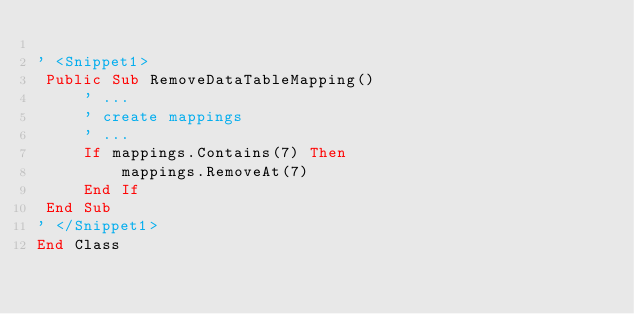<code> <loc_0><loc_0><loc_500><loc_500><_VisualBasic_>    
' <Snippet1>
 Public Sub RemoveDataTableMapping()
     ' ...
     ' create mappings
     ' ...
     If mappings.Contains(7) Then
         mappings.RemoveAt(7)
     End If
 End Sub
' </Snippet1>
End Class
</code> 